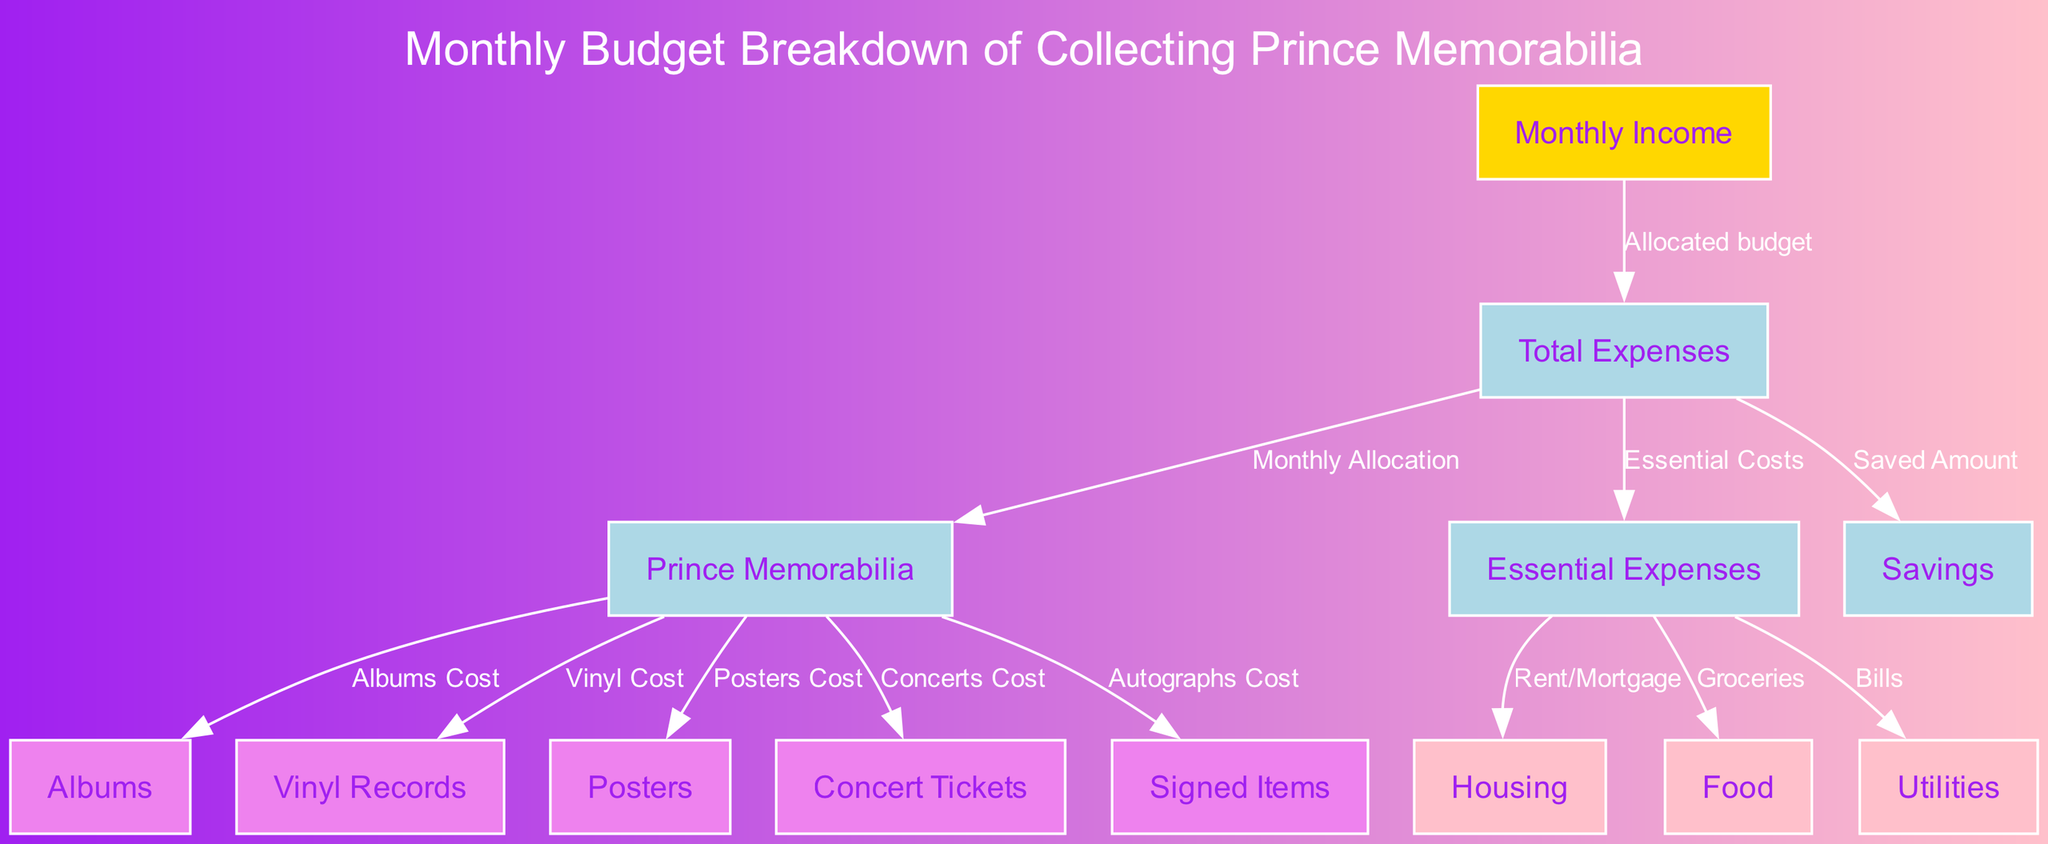what is the monthly income category in this diagram? The diagram indicates a node labeled "Monthly Income." This is the starting point of the budget breakdown and is crucial for understanding how funds are allocated.
Answer: Monthly Income how many types of memorabilia expenses are represented in the diagram? There are five specific expenses associated with Prince memorabilia: Albums, Vinyl Records, Posters, Concert Tickets, and Signed Items. These are shown as separate nodes connected to the "Prince Memorabilia" node.
Answer: 5 what is the connection between total expenses and savings? The "Total Expenses" node has a directed edge leading to the "Savings" node, indicating that a portion of the total expenses is dedicated to saving. This shows a flow of budget from total expenses to savings.
Answer: Saved Amount which expense is associated with housing in the essentials category? The connection is made from "Essential Expenses" to a node labeled "Housing," indicated as Rent/Mortgage. This indicates that spending on housing is categorized under essential expenses.
Answer: Rent/Mortgage how does the monthly budget allocate between essential expenses and memorabilia expenses? Both "Essential Expenses" and "Prince Memorabilia" are connected to the "Total Expenses" node, hinting that the budget is split between essential living costs and hobbies/collectibles related to Prince, yet no specific values are provided in the diagram.
Answer: Monthly Allocation what does the edge labeled “Allocated budget” signify? This edge indicates that the amount to be spent on total expenses is directly derived from the monthly income, establishing a foundational financial structure in the diagram to manage overall spending.
Answer: Allocated budget which node represents the cost of concert tickets? The node for concert ticket expenses is labeled "Concert Tickets." This indicates that there is a specific allocation in the budget for attending concerts, which represents a component of memorabilia expenses.
Answer: Concert Tickets what does the edge labeled “Essential Costs” indicate? This edge connects "Total Expenses" to "Essential Expenses," highlighting that essential costs are represented as part of the overall spending, emphasizing its importance in budgeting.
Answer: Essential Costs 